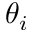<formula> <loc_0><loc_0><loc_500><loc_500>\theta _ { i }</formula> 